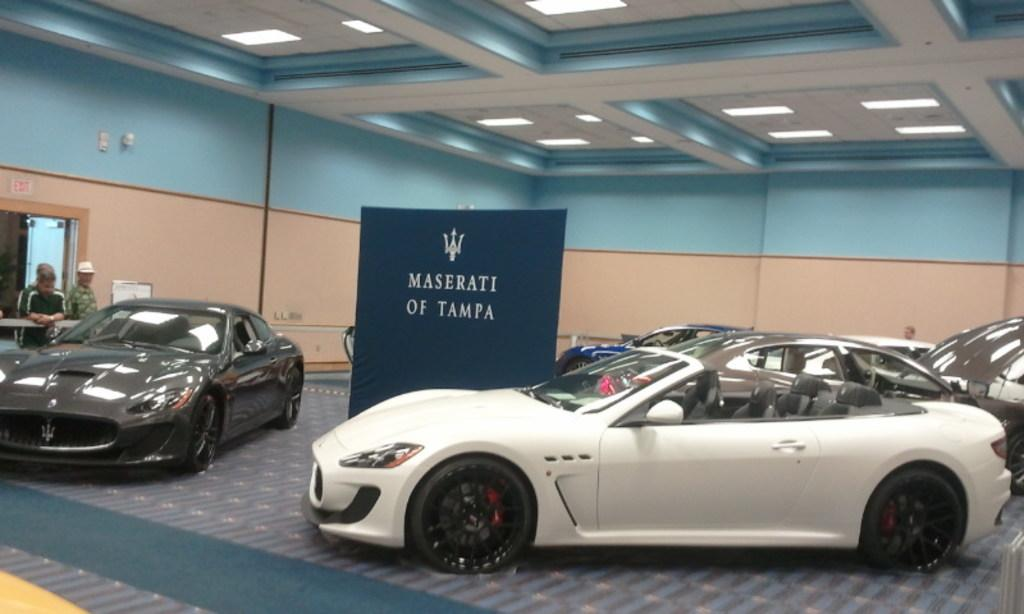What type of vehicle is on the right side of the image? There is a white color car on the right side of the image. What is the position of the other car in the image? Another car is parked on the left side of the image. Can you describe any specific features of the vehicles in the image? There are lights on the roof in the image. Is there a mask-wearing cook riding a horse in the image? No, there is no mask-wearing cook riding a horse in the image. 